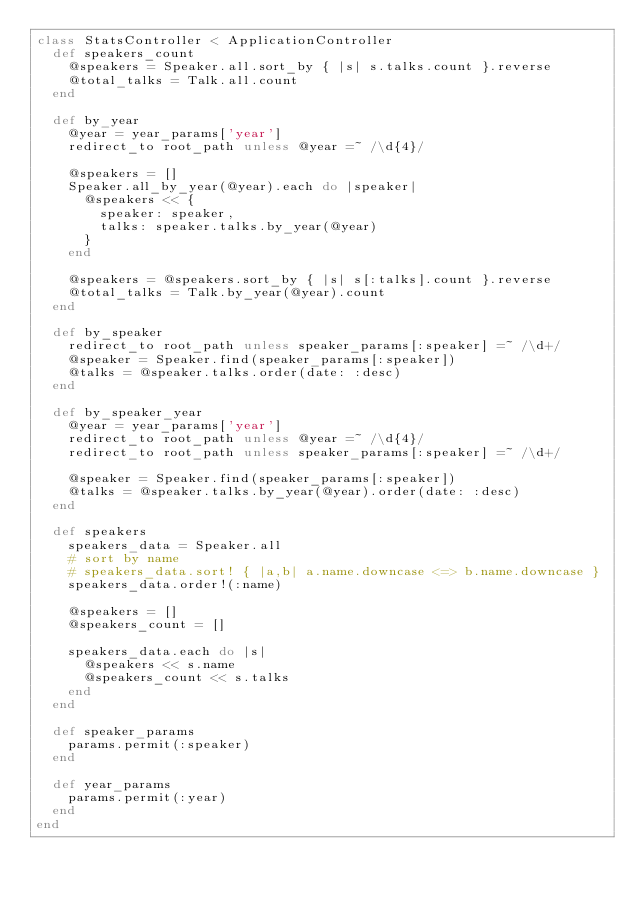Convert code to text. <code><loc_0><loc_0><loc_500><loc_500><_Ruby_>class StatsController < ApplicationController
  def speakers_count
    @speakers = Speaker.all.sort_by { |s| s.talks.count }.reverse
    @total_talks = Talk.all.count
  end

  def by_year
    @year = year_params['year']
    redirect_to root_path unless @year =~ /\d{4}/

    @speakers = []
    Speaker.all_by_year(@year).each do |speaker|
      @speakers << {
        speaker: speaker,
        talks: speaker.talks.by_year(@year)
      }
    end

    @speakers = @speakers.sort_by { |s| s[:talks].count }.reverse
    @total_talks = Talk.by_year(@year).count
  end

  def by_speaker
    redirect_to root_path unless speaker_params[:speaker] =~ /\d+/
    @speaker = Speaker.find(speaker_params[:speaker])
    @talks = @speaker.talks.order(date: :desc)
  end

  def by_speaker_year
    @year = year_params['year']
    redirect_to root_path unless @year =~ /\d{4}/
    redirect_to root_path unless speaker_params[:speaker] =~ /\d+/

    @speaker = Speaker.find(speaker_params[:speaker])
    @talks = @speaker.talks.by_year(@year).order(date: :desc)
  end

  def speakers
    speakers_data = Speaker.all
    # sort by name
    # speakers_data.sort! { |a,b| a.name.downcase <=> b.name.downcase }
    speakers_data.order!(:name)

    @speakers = []
    @speakers_count = []

    speakers_data.each do |s|
      @speakers << s.name
      @speakers_count << s.talks
    end
  end

  def speaker_params
    params.permit(:speaker)
  end

  def year_params
    params.permit(:year)
  end
end
</code> 